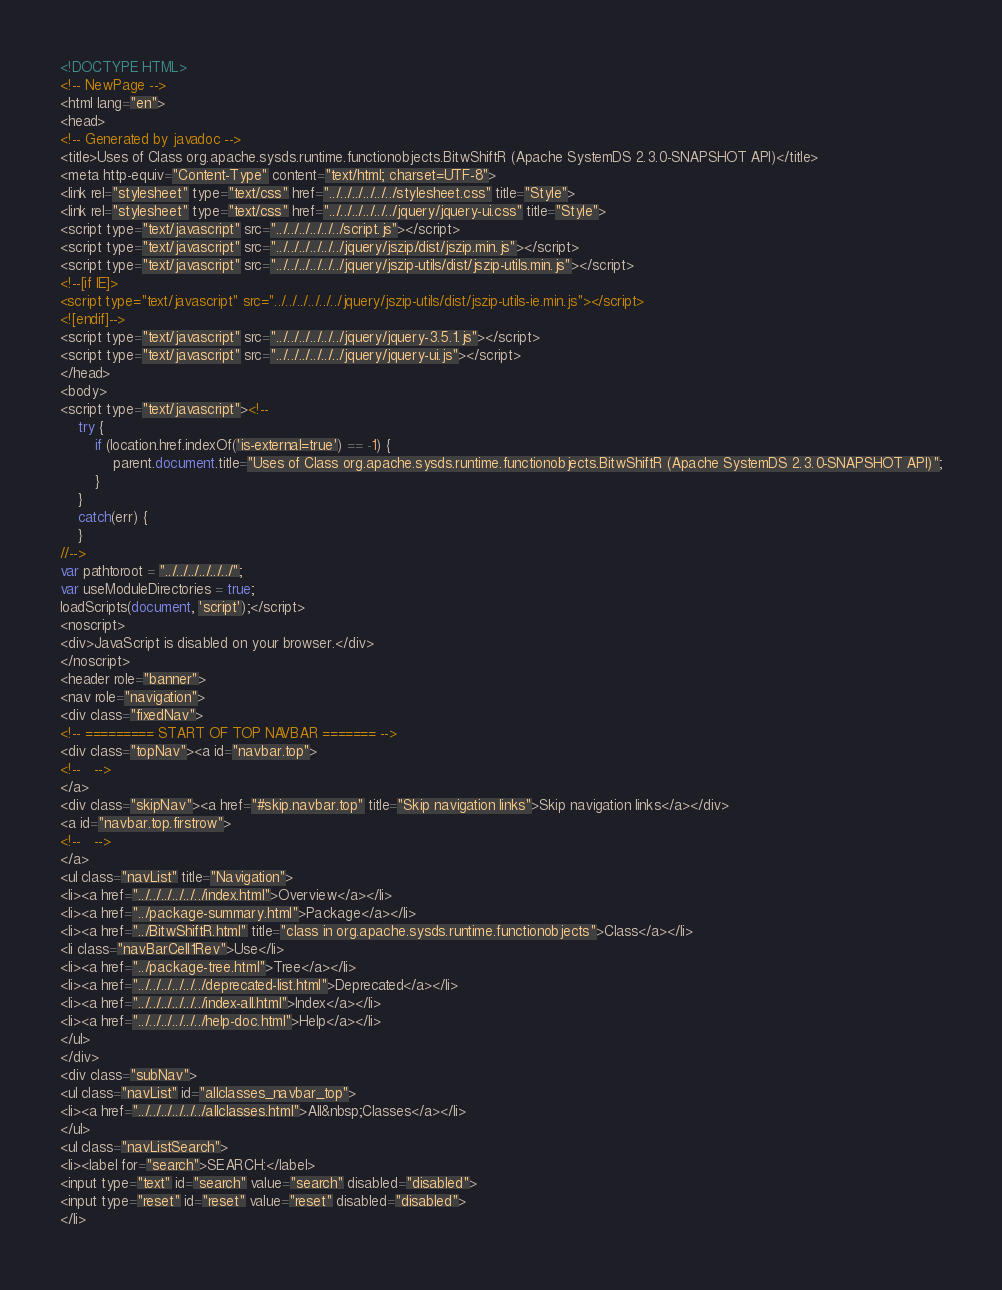<code> <loc_0><loc_0><loc_500><loc_500><_HTML_><!DOCTYPE HTML>
<!-- NewPage -->
<html lang="en">
<head>
<!-- Generated by javadoc -->
<title>Uses of Class org.apache.sysds.runtime.functionobjects.BitwShiftR (Apache SystemDS 2.3.0-SNAPSHOT API)</title>
<meta http-equiv="Content-Type" content="text/html; charset=UTF-8">
<link rel="stylesheet" type="text/css" href="../../../../../../stylesheet.css" title="Style">
<link rel="stylesheet" type="text/css" href="../../../../../../jquery/jquery-ui.css" title="Style">
<script type="text/javascript" src="../../../../../../script.js"></script>
<script type="text/javascript" src="../../../../../../jquery/jszip/dist/jszip.min.js"></script>
<script type="text/javascript" src="../../../../../../jquery/jszip-utils/dist/jszip-utils.min.js"></script>
<!--[if IE]>
<script type="text/javascript" src="../../../../../../jquery/jszip-utils/dist/jszip-utils-ie.min.js"></script>
<![endif]-->
<script type="text/javascript" src="../../../../../../jquery/jquery-3.5.1.js"></script>
<script type="text/javascript" src="../../../../../../jquery/jquery-ui.js"></script>
</head>
<body>
<script type="text/javascript"><!--
    try {
        if (location.href.indexOf('is-external=true') == -1) {
            parent.document.title="Uses of Class org.apache.sysds.runtime.functionobjects.BitwShiftR (Apache SystemDS 2.3.0-SNAPSHOT API)";
        }
    }
    catch(err) {
    }
//-->
var pathtoroot = "../../../../../../";
var useModuleDirectories = true;
loadScripts(document, 'script');</script>
<noscript>
<div>JavaScript is disabled on your browser.</div>
</noscript>
<header role="banner">
<nav role="navigation">
<div class="fixedNav">
<!-- ========= START OF TOP NAVBAR ======= -->
<div class="topNav"><a id="navbar.top">
<!--   -->
</a>
<div class="skipNav"><a href="#skip.navbar.top" title="Skip navigation links">Skip navigation links</a></div>
<a id="navbar.top.firstrow">
<!--   -->
</a>
<ul class="navList" title="Navigation">
<li><a href="../../../../../../index.html">Overview</a></li>
<li><a href="../package-summary.html">Package</a></li>
<li><a href="../BitwShiftR.html" title="class in org.apache.sysds.runtime.functionobjects">Class</a></li>
<li class="navBarCell1Rev">Use</li>
<li><a href="../package-tree.html">Tree</a></li>
<li><a href="../../../../../../deprecated-list.html">Deprecated</a></li>
<li><a href="../../../../../../index-all.html">Index</a></li>
<li><a href="../../../../../../help-doc.html">Help</a></li>
</ul>
</div>
<div class="subNav">
<ul class="navList" id="allclasses_navbar_top">
<li><a href="../../../../../../allclasses.html">All&nbsp;Classes</a></li>
</ul>
<ul class="navListSearch">
<li><label for="search">SEARCH:</label>
<input type="text" id="search" value="search" disabled="disabled">
<input type="reset" id="reset" value="reset" disabled="disabled">
</li></code> 